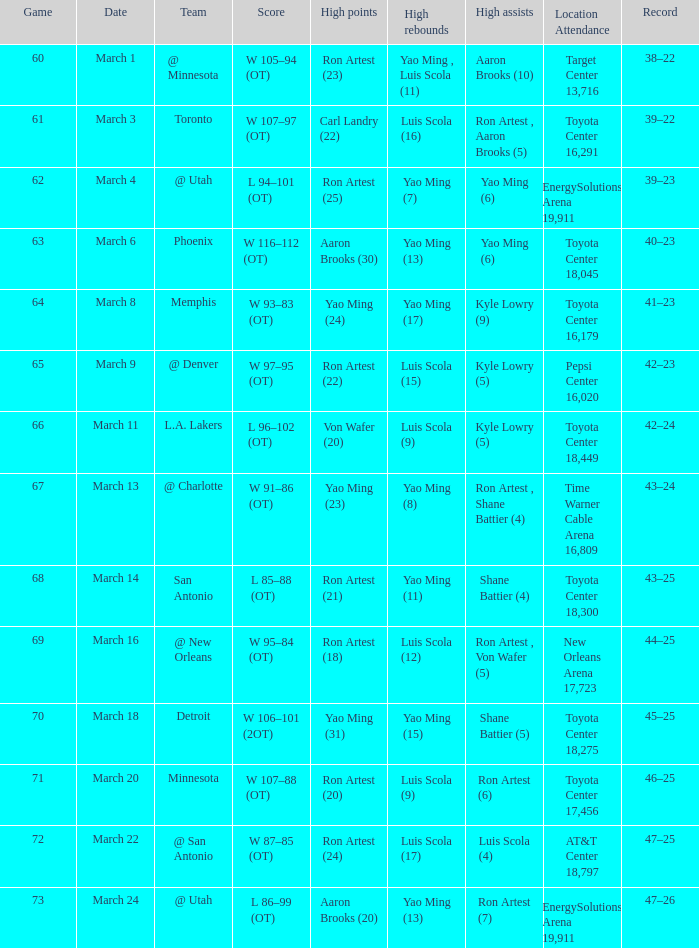Who earned the most points during game 72? Ron Artest (24). 